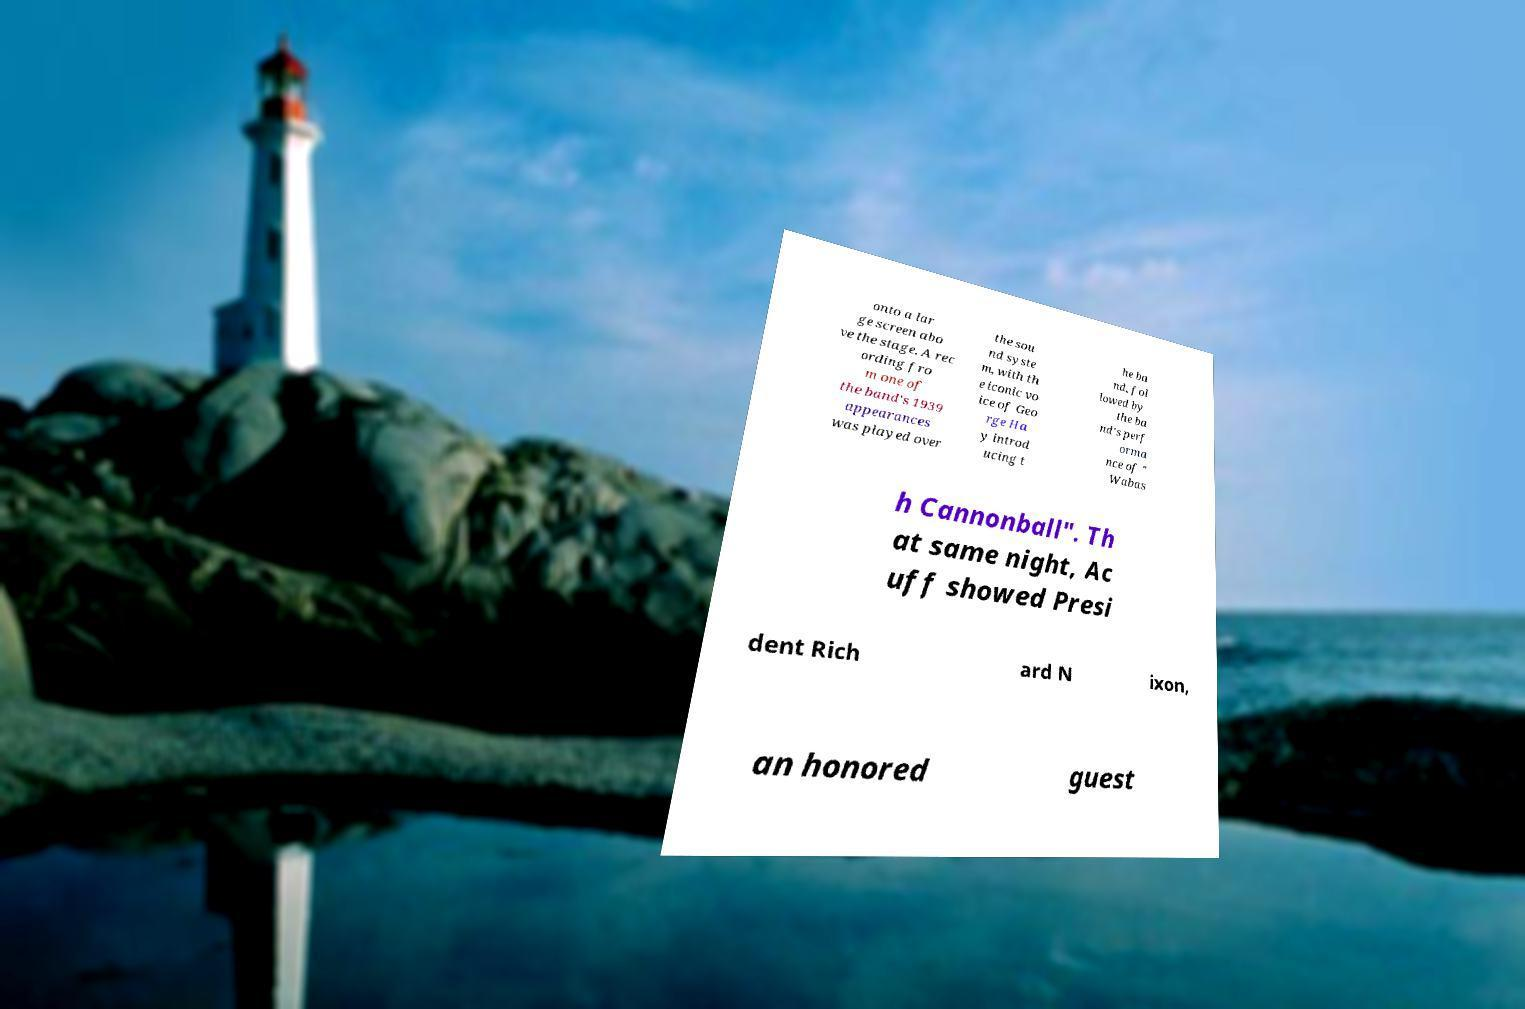For documentation purposes, I need the text within this image transcribed. Could you provide that? onto a lar ge screen abo ve the stage. A rec ording fro m one of the band's 1939 appearances was played over the sou nd syste m, with th e iconic vo ice of Geo rge Ha y introd ucing t he ba nd, fol lowed by the ba nd's perf orma nce of " Wabas h Cannonball". Th at same night, Ac uff showed Presi dent Rich ard N ixon, an honored guest 